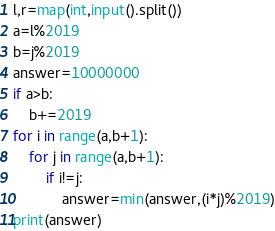Convert code to text. <code><loc_0><loc_0><loc_500><loc_500><_Python_>l,r=map(int,input().split())
a=l%2019
b=j%2019
answer=10000000
if a>b:
    b+=2019
for i in range(a,b+1):
    for j in range(a,b+1):
        if i!=j:
            answer=min(answer,(i*j)%2019)
print(answer)</code> 